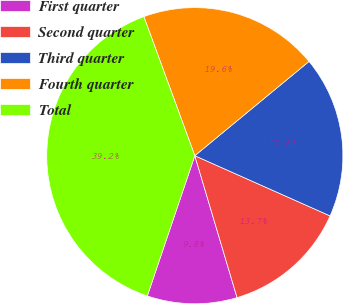Convert chart to OTSL. <chart><loc_0><loc_0><loc_500><loc_500><pie_chart><fcel>First quarter<fcel>Second quarter<fcel>Third quarter<fcel>Fourth quarter<fcel>Total<nl><fcel>9.8%<fcel>13.73%<fcel>17.65%<fcel>19.61%<fcel>39.22%<nl></chart> 